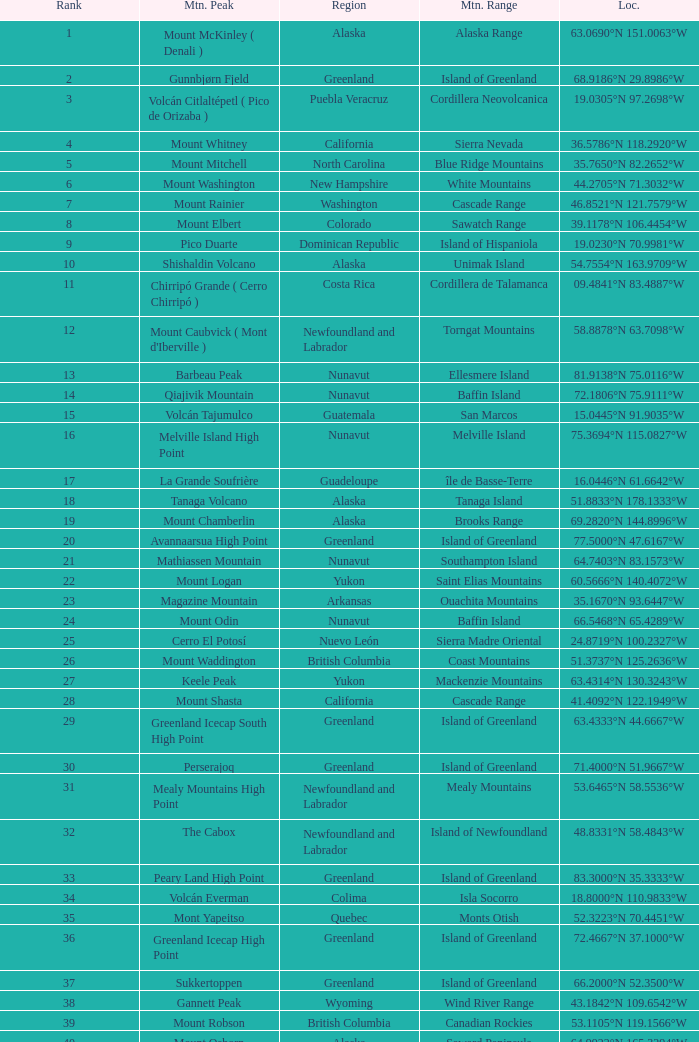Which peak, located at 28.1301°n 115.2206°w, belongs to the baja california region? Isla Cedros High Point. 